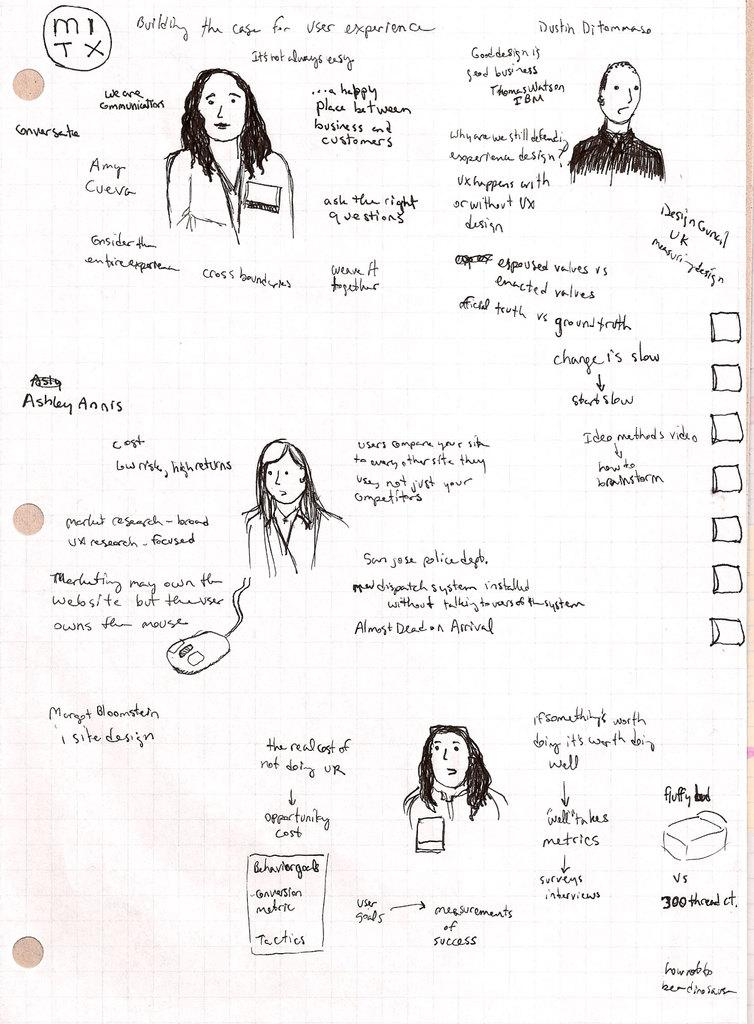What is present on the paper in the image? There is text and sketches of persons on the paper. How is the text distributed on the paper? The text is scattered all over the paper. How are the sketches of persons distributed on the paper? The sketches are scattered all over the paper. What type of mint is growing near the door in the image? There is no mention of mint or a door in the image; it only features a paper with text and sketches. 